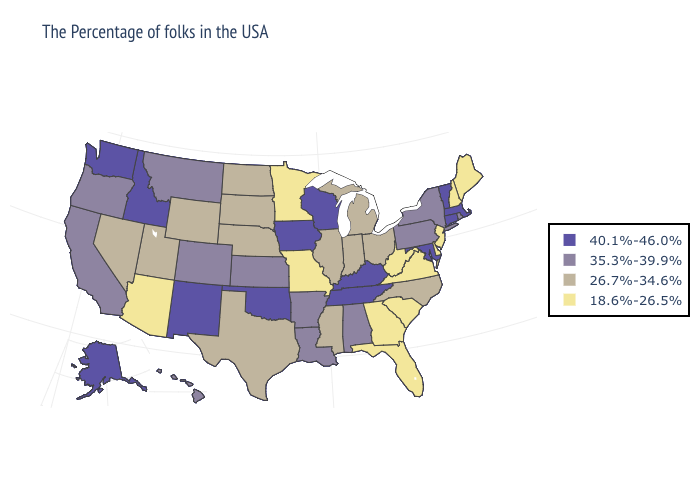Name the states that have a value in the range 18.6%-26.5%?
Give a very brief answer. Maine, New Hampshire, New Jersey, Delaware, Virginia, South Carolina, West Virginia, Florida, Georgia, Missouri, Minnesota, Arizona. Name the states that have a value in the range 40.1%-46.0%?
Be succinct. Massachusetts, Vermont, Connecticut, Maryland, Kentucky, Tennessee, Wisconsin, Iowa, Oklahoma, New Mexico, Idaho, Washington, Alaska. Name the states that have a value in the range 40.1%-46.0%?
Be succinct. Massachusetts, Vermont, Connecticut, Maryland, Kentucky, Tennessee, Wisconsin, Iowa, Oklahoma, New Mexico, Idaho, Washington, Alaska. Name the states that have a value in the range 18.6%-26.5%?
Write a very short answer. Maine, New Hampshire, New Jersey, Delaware, Virginia, South Carolina, West Virginia, Florida, Georgia, Missouri, Minnesota, Arizona. Does Maryland have a higher value than Arizona?
Quick response, please. Yes. Which states hav the highest value in the South?
Short answer required. Maryland, Kentucky, Tennessee, Oklahoma. Name the states that have a value in the range 18.6%-26.5%?
Keep it brief. Maine, New Hampshire, New Jersey, Delaware, Virginia, South Carolina, West Virginia, Florida, Georgia, Missouri, Minnesota, Arizona. What is the highest value in the USA?
Answer briefly. 40.1%-46.0%. Name the states that have a value in the range 26.7%-34.6%?
Quick response, please. North Carolina, Ohio, Michigan, Indiana, Illinois, Mississippi, Nebraska, Texas, South Dakota, North Dakota, Wyoming, Utah, Nevada. Does New Jersey have the highest value in the USA?
Concise answer only. No. Name the states that have a value in the range 26.7%-34.6%?
Give a very brief answer. North Carolina, Ohio, Michigan, Indiana, Illinois, Mississippi, Nebraska, Texas, South Dakota, North Dakota, Wyoming, Utah, Nevada. What is the value of Wyoming?
Concise answer only. 26.7%-34.6%. Does the first symbol in the legend represent the smallest category?
Keep it brief. No. Among the states that border Massachusetts , which have the highest value?
Give a very brief answer. Vermont, Connecticut. What is the value of Mississippi?
Keep it brief. 26.7%-34.6%. 